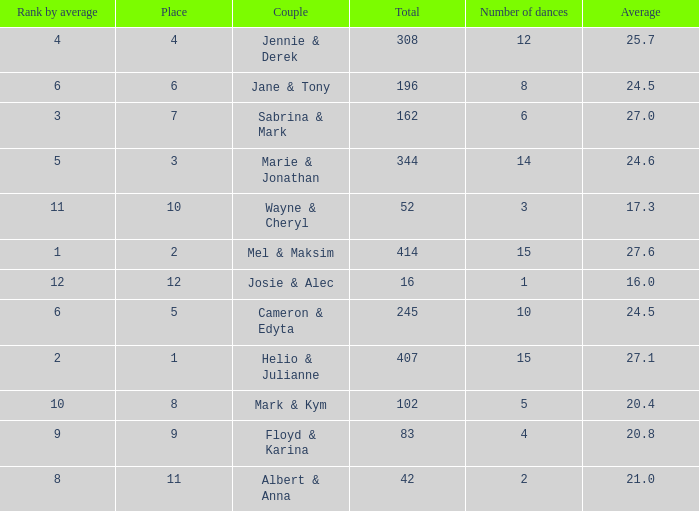What is the rank by average where the total was larger than 245 and the average was 27.1 with fewer than 15 dances? None. 